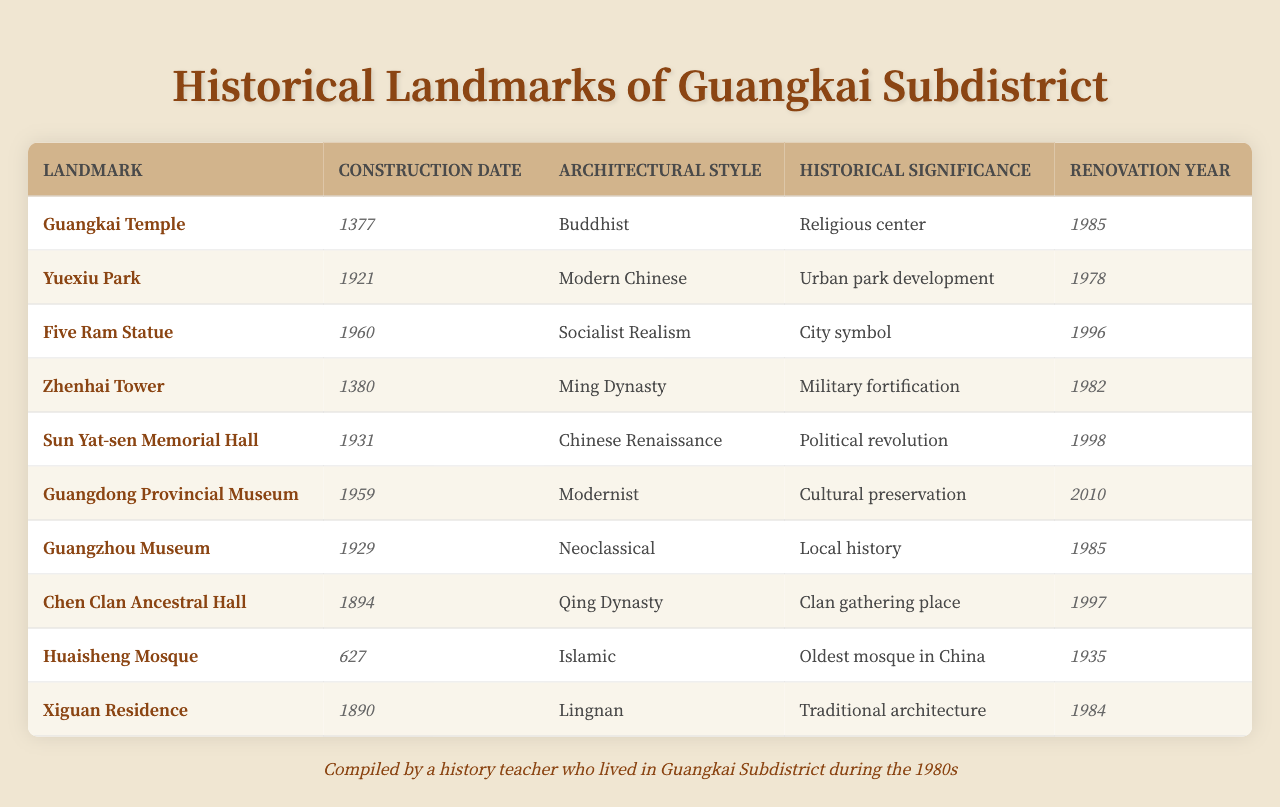What is the construction date of Guangkai Temple? The construction date of Guangkai Temple is listed in the table under the "Construction Date" column beside the landmark “Guangkai Temple.” It is 1377.
Answer: 1377 Which landmark was renovated the latest? The "Renovation Year" column can be checked for the highest year entry. The most recent renovation date is 2010, which corresponds to the Guangdong Provincial Museum.
Answer: Guangdong Provincial Museum How many landmarks were constructed in the Ming Dynasty? By checking the "Architectural Style" column, we see that only Guangkai Temple (1377) and Zhenhai Tower (1380) are listed as Ming Dynasty, which totals to 2 landmarks.
Answer: 2 Did the Five Ram Statue have any renovations before 2000? The renovation year for the Five Ram Statue is 1996, which is before 2000. As such, the statement is true.
Answer: Yes What is the average construction year of the landmarks? First, we sum up all the construction years: 1377 + 1921 + 1960 + 1380 + 1931 + 1959 + 1929 + 1894 + 627 + 1890 = 11476. There are 10 landmarks, so the average year is 11476 / 10 = 1147.6, which rounds to 1148.
Answer: 1148 Which style of architecture is most commonly represented among the landmarks? Looking through the "Architectural Style" column, we find that no style appears more than once except for “Modern Chinese” with 1 occurrence, while others are unique. Thus, there's not a distinct popular style among these landmarks.
Answer: None How many landmarks were built in the 19th century? The 19th century corresponds to years 1800-1899. Checking the construction dates, we find the Chen Clan Ancestral Hall (1894), Huaisheng Mosque (627), and Xiguan Residence (1890) count to 3 landmarks built in that century.
Answer: 3 What is the historical significance of the Huaisheng Mosque? The table indicates that the historical significance of the Huaisheng Mosque is “Oldest mosque in China,” which highlights its importance historically among landmarks.
Answer: Oldest mosque in China Which landmark had renovations both in the 20th and 21st centuries? By checking the "Renovation Year," we find that Guangdong Provincial Museum was renovated in 2010 (21st century) and before that in 1959 (20th century).
Answer: Guangdong Provincial Museum Is the Five Ram Statue older than the Sun Yat-sen Memorial Hall? The construction date of the Five Ram Statue is 1960, while the Sun Yat-sen Memorial Hall was constructed in 1931. Since 1960 is later than 1931, the statement is false.
Answer: No 